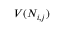<formula> <loc_0><loc_0><loc_500><loc_500>V ( N _ { i , j } )</formula> 